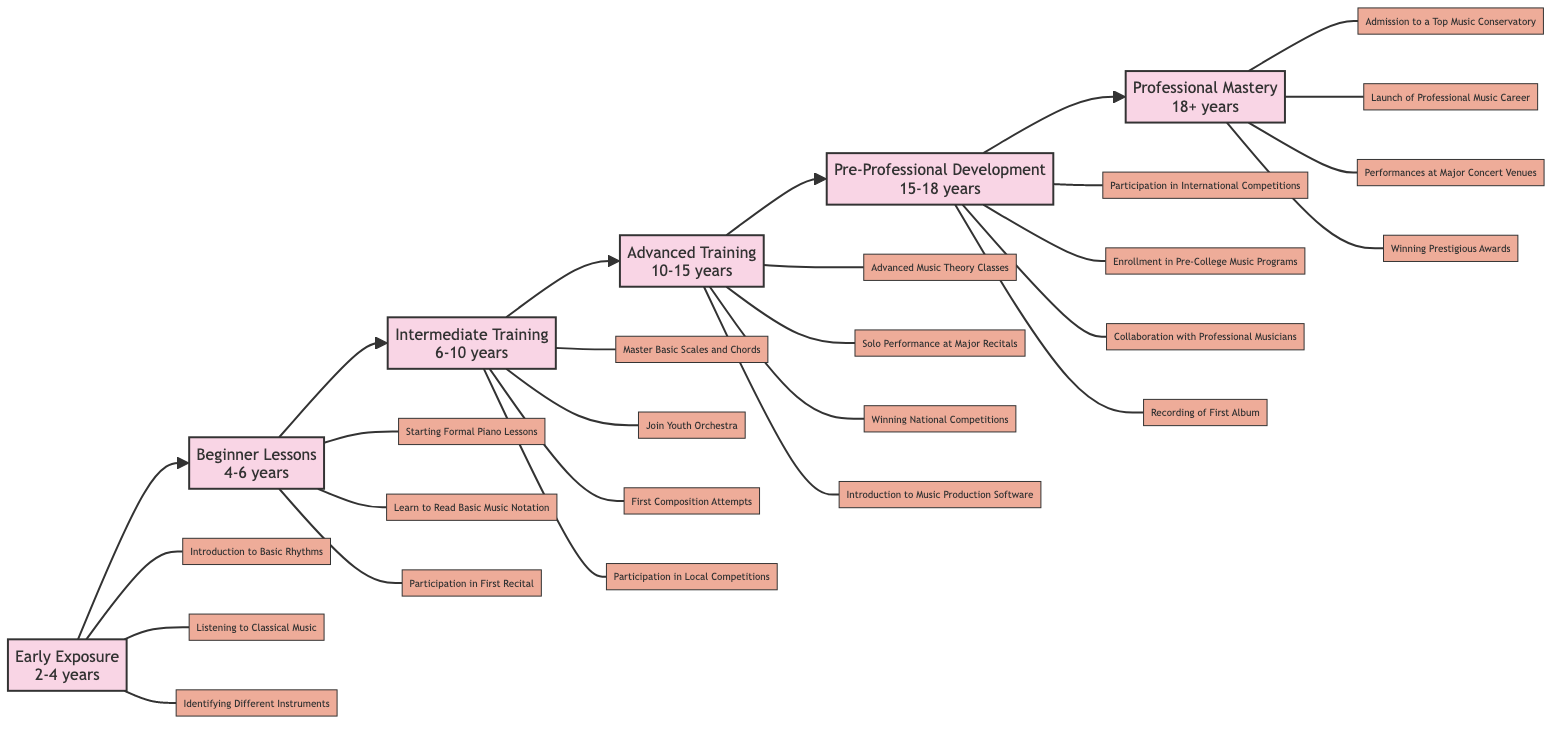What's the age range for Early Exposure? The Early Exposure stage in the flowchart indicates an age range of 2 to 4 years. This can be found directly under the "Early Exposure" node in the diagram.
Answer: 2-4 years How many milestones are listed under Intermediate Training? Under the Intermediate Training stage, there are four milestones mentioned. These milestones are connected directly to the Intermediate Training node in the flowchart.
Answer: 4 What is the first milestone in the Beginner Lessons? The first milestone listed under the Beginner Lessons stage is "Starting Formal Piano Lessons," which can be identified at the beginning of the corresponding section in the diagram.
Answer: Starting Formal Piano Lessons Which stage comes immediately after Advanced Training? The flowchart has arrows indicating the progression from Advanced Training to Pre-Professional Development. Thus, Pre-Professional Development comes immediately after Advanced Training.
Answer: Pre-Professional Development What milestone corresponds with the age 15-18 years? The age range of 15 to 18 years corresponds with the "Participation in International Competitions," which is the first milestone listed under the Pre-Professional Development stage. This information can be seen in the appropriate node and its connected milestones.
Answer: Participation in International Competitions Which edge connects Beginner Lessons to Intermediate Training? The arrow representing the flow from Beginner Lessons to Intermediate Training can be found directly above the related nodes in the diagram. This directional edge highlights the transition point between these two stages of musical education.
Answer: The edge What is the last milestone in the Professional Mastery stage? The last milestone in the Professional Mastery stage is "Winning Prestigious Awards." This can be seen as the final item listed in the Professional Mastery section of the diagram.
Answer: Winning Prestigious Awards Which two stages have a total of three milestones? By examining the flowchart, we can see that both Beginner Lessons and Advanced Training have three milestones listed underneath them. Thus, these two stages meet the criteria given.
Answer: Beginner Lessons, Advanced Training How many total stages are there in the musical education timeline? Counting the stages displayed in the flowchart, there are a total of six stages: Early Exposure, Beginner Lessons, Intermediate Training, Advanced Training, Pre-Professional Development, and Professional Mastery. This is derived by simply noting each major node depicted.
Answer: 6 